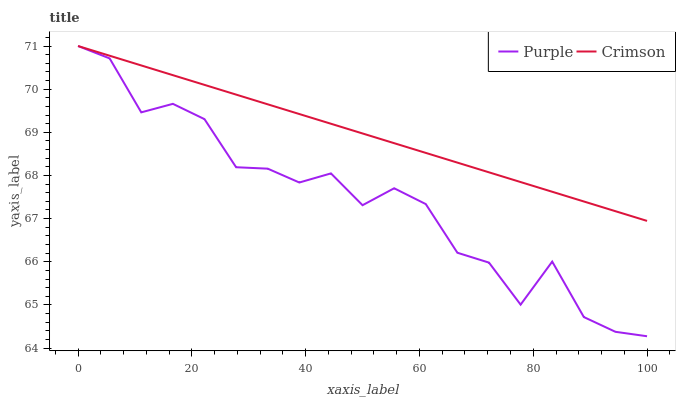Does Purple have the minimum area under the curve?
Answer yes or no. Yes. Does Crimson have the maximum area under the curve?
Answer yes or no. Yes. Does Crimson have the minimum area under the curve?
Answer yes or no. No. Is Crimson the smoothest?
Answer yes or no. Yes. Is Purple the roughest?
Answer yes or no. Yes. Is Crimson the roughest?
Answer yes or no. No. Does Purple have the lowest value?
Answer yes or no. Yes. Does Crimson have the lowest value?
Answer yes or no. No. Does Crimson have the highest value?
Answer yes or no. Yes. Does Crimson intersect Purple?
Answer yes or no. Yes. Is Crimson less than Purple?
Answer yes or no. No. Is Crimson greater than Purple?
Answer yes or no. No. 